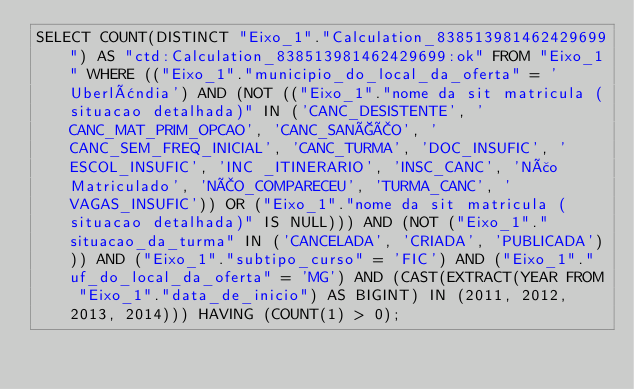<code> <loc_0><loc_0><loc_500><loc_500><_SQL_>SELECT COUNT(DISTINCT "Eixo_1"."Calculation_838513981462429699") AS "ctd:Calculation_838513981462429699:ok" FROM "Eixo_1" WHERE (("Eixo_1"."municipio_do_local_da_oferta" = 'Uberlândia') AND (NOT (("Eixo_1"."nome da sit matricula (situacao detalhada)" IN ('CANC_DESISTENTE', 'CANC_MAT_PRIM_OPCAO', 'CANC_SANÇÃO', 'CANC_SEM_FREQ_INICIAL', 'CANC_TURMA', 'DOC_INSUFIC', 'ESCOL_INSUFIC', 'INC _ITINERARIO', 'INSC_CANC', 'Não Matriculado', 'NÃO_COMPARECEU', 'TURMA_CANC', 'VAGAS_INSUFIC')) OR ("Eixo_1"."nome da sit matricula (situacao detalhada)" IS NULL))) AND (NOT ("Eixo_1"."situacao_da_turma" IN ('CANCELADA', 'CRIADA', 'PUBLICADA'))) AND ("Eixo_1"."subtipo_curso" = 'FIC') AND ("Eixo_1"."uf_do_local_da_oferta" = 'MG') AND (CAST(EXTRACT(YEAR FROM "Eixo_1"."data_de_inicio") AS BIGINT) IN (2011, 2012, 2013, 2014))) HAVING (COUNT(1) > 0);
</code> 